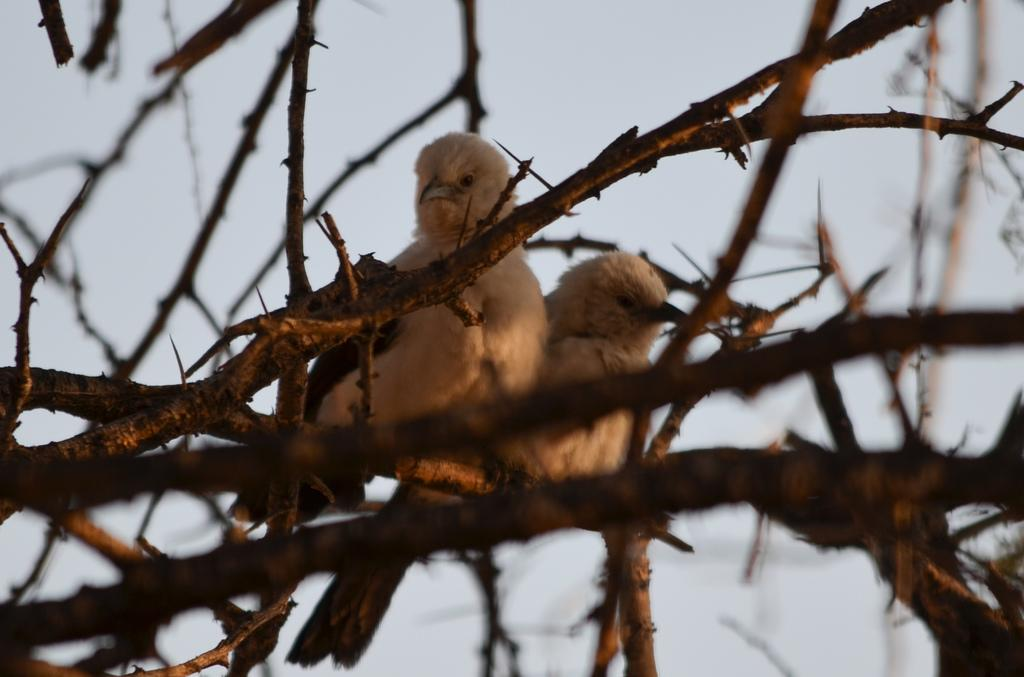What type of animals can be seen in the image? There are birds in the middle of the image. What is the birds situated on? The birds are situated on branches of a tree in the image. What type of growth can be seen on the cemetery in the image? There is no cemetery present in the image; it features birds on branches of a tree. What type of chain is visible connecting the birds in the image? There is no chain connecting the birds in the image; they are perched on separate branches. 